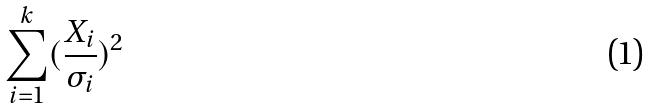<formula> <loc_0><loc_0><loc_500><loc_500>\sum _ { i = 1 } ^ { k } ( \frac { X _ { i } } { \sigma _ { i } } ) ^ { 2 }</formula> 